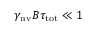<formula> <loc_0><loc_0><loc_500><loc_500>\gamma _ { n v } B \tau _ { t o t } \ll 1</formula> 